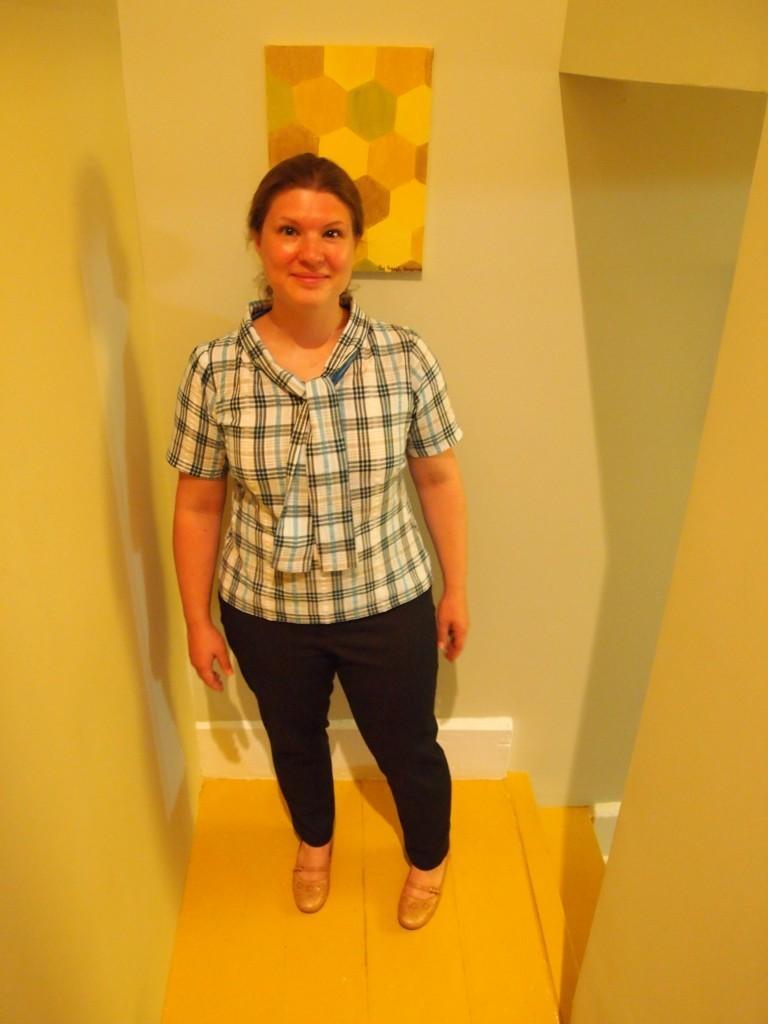Please provide a concise description of this image. In the foreground I can see a woman on the floor. In the background I can see a wall. This image is taken may be in a room. 